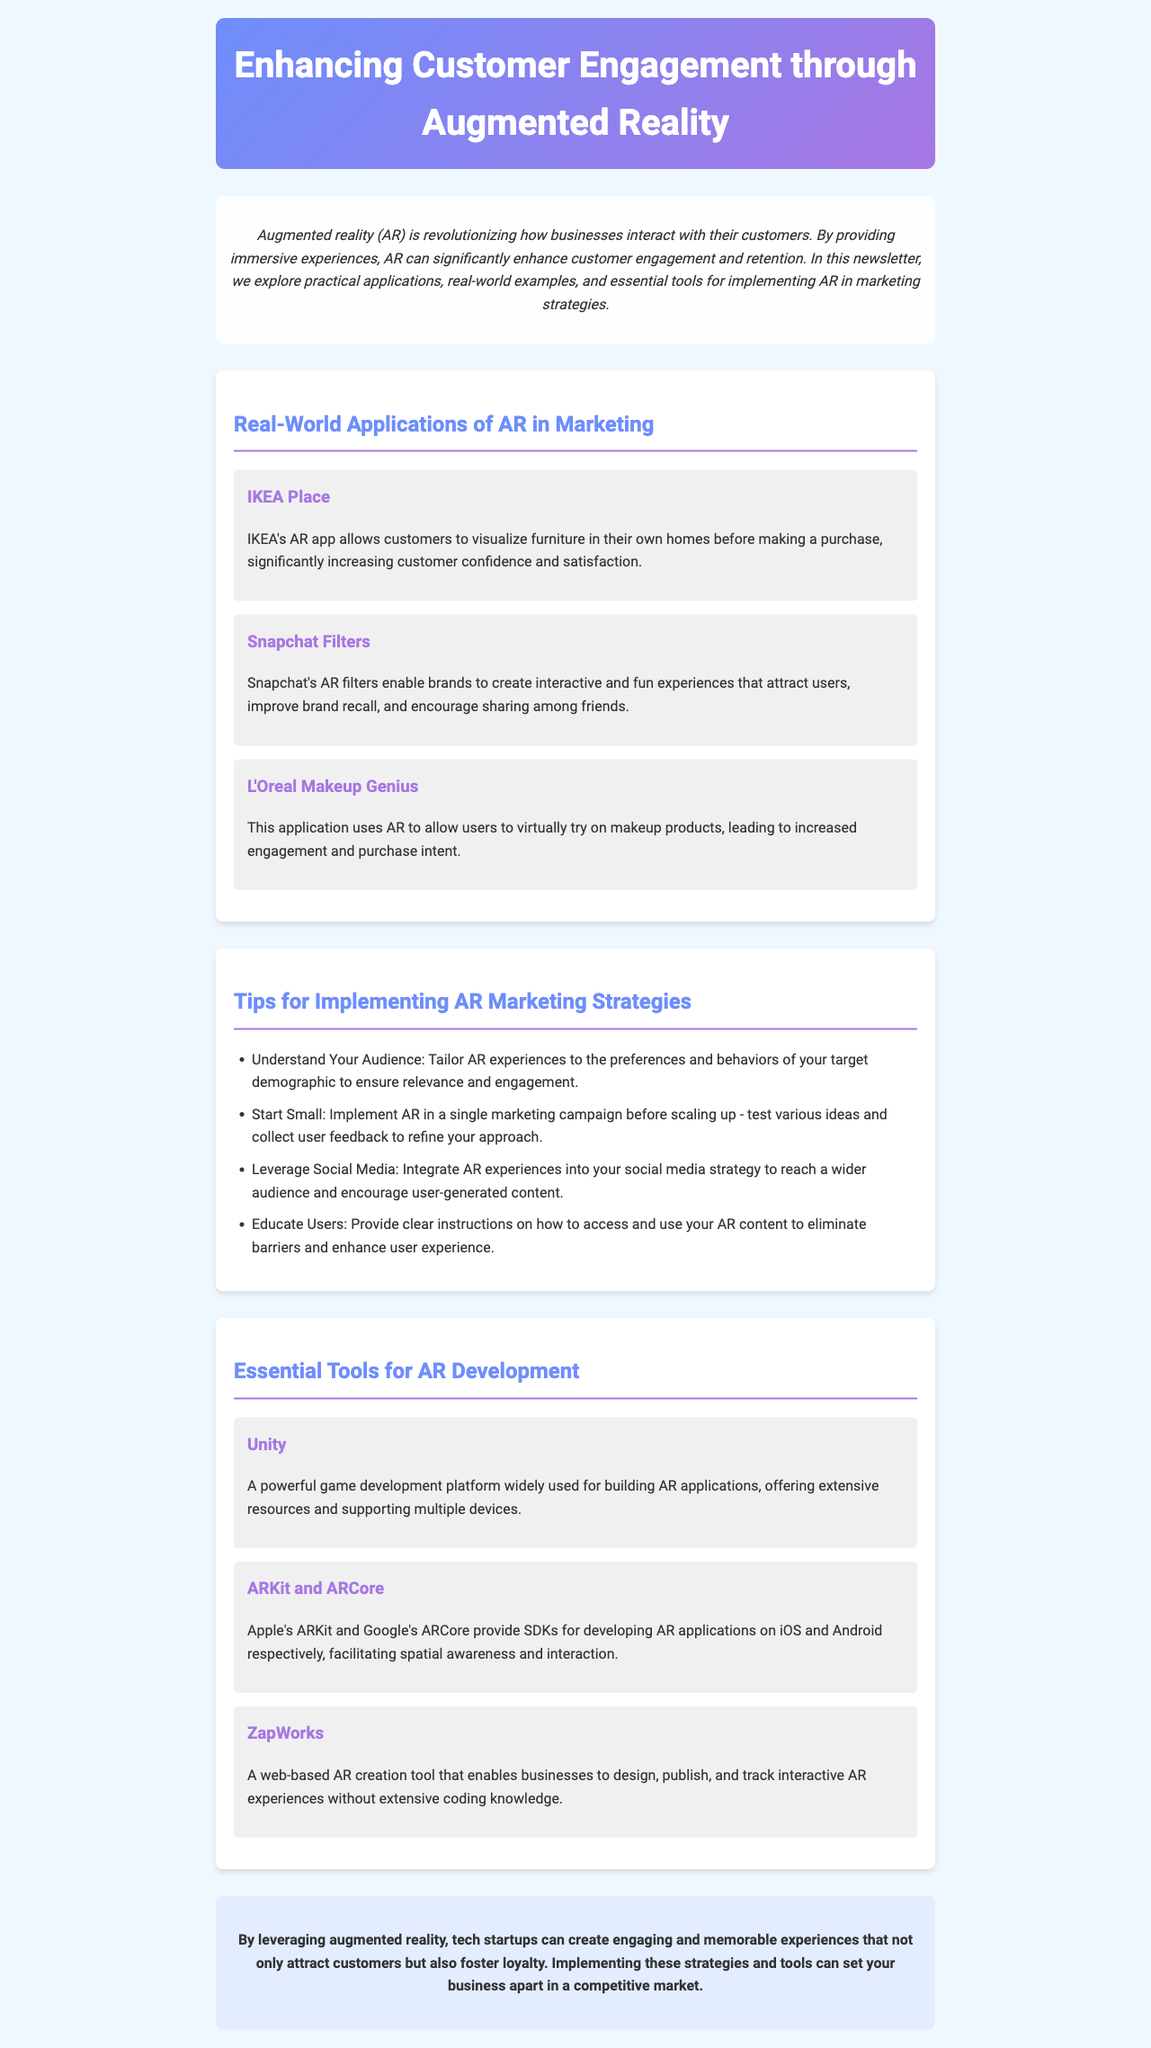What is the title of the newsletter? The title of the newsletter is provided in the header of the document.
Answer: Enhancing Customer Engagement through Augmented Reality What are two examples of AR applications mentioned? The document lists several AR applications under the real-world applications section that enhance customer engagement.
Answer: IKEA Place, Snapchat Filters What key benefit does IKEA's AR app provide to customers? The document describes how IKEA's AR app helps customers visualize products, which enhances their purchasing experience.
Answer: Visualizing furniture in homes How many tips for implementing AR marketing strategies are listed? The document specifies a number of tips in a dedicated section on AR marketing strategies.
Answer: Four What is one essential tool for AR development mentioned? The document enumerates various tools for developing AR applications in the essential tools section.
Answer: Unity What is the main focus of the newsletter? The introduction summarizes the objective of the newsletter, which is related to customer engagement through a specific technology.
Answer: Customer engagement through augmented reality Which social media strategy is suggested for integrating AR? The document provides a tip on how social media can be used alongside AR experiences for broader reach.
Answer: Leverage social media What is the purpose of the conclusion? The conclusion reiterates the overall potential benefits of AR for businesses as described in the newsletter.
Answer: Foster loyalty 